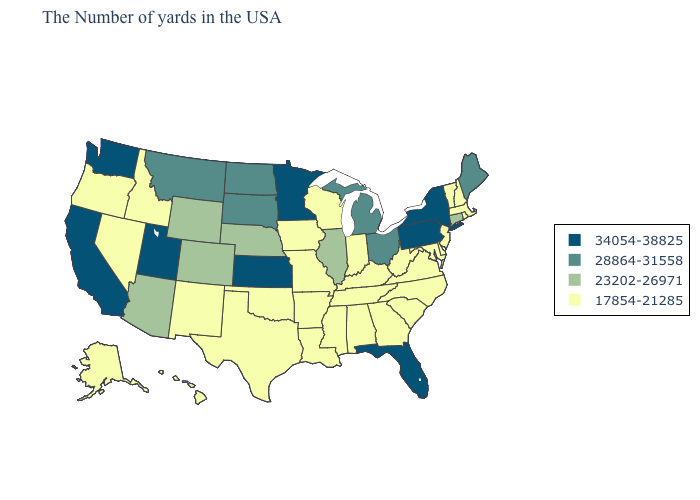How many symbols are there in the legend?
Concise answer only. 4. Name the states that have a value in the range 17854-21285?
Short answer required. Massachusetts, Rhode Island, New Hampshire, Vermont, New Jersey, Delaware, Maryland, Virginia, North Carolina, South Carolina, West Virginia, Georgia, Kentucky, Indiana, Alabama, Tennessee, Wisconsin, Mississippi, Louisiana, Missouri, Arkansas, Iowa, Oklahoma, Texas, New Mexico, Idaho, Nevada, Oregon, Alaska, Hawaii. Does Florida have the same value as Pennsylvania?
Answer briefly. Yes. Name the states that have a value in the range 28864-31558?
Keep it brief. Maine, Ohio, Michigan, South Dakota, North Dakota, Montana. Among the states that border Missouri , which have the lowest value?
Be succinct. Kentucky, Tennessee, Arkansas, Iowa, Oklahoma. How many symbols are there in the legend?
Concise answer only. 4. Does Maryland have a higher value than Kansas?
Give a very brief answer. No. Among the states that border Missouri , does Kentucky have the lowest value?
Write a very short answer. Yes. What is the highest value in the USA?
Answer briefly. 34054-38825. Name the states that have a value in the range 28864-31558?
Be succinct. Maine, Ohio, Michigan, South Dakota, North Dakota, Montana. Among the states that border Wyoming , which have the highest value?
Answer briefly. Utah. Does Iowa have a lower value than Arizona?
Be succinct. Yes. Is the legend a continuous bar?
Keep it brief. No. Name the states that have a value in the range 28864-31558?
Answer briefly. Maine, Ohio, Michigan, South Dakota, North Dakota, Montana. What is the value of Nebraska?
Short answer required. 23202-26971. 